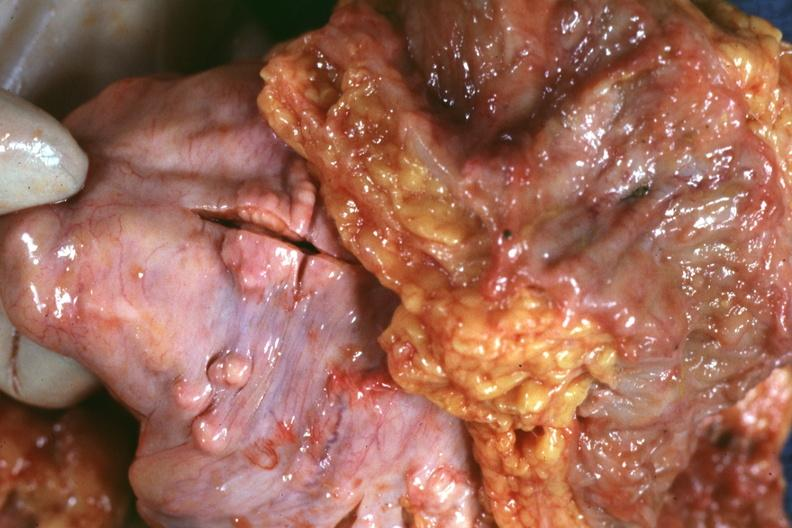s metastatic carcinoma prostate present?
Answer the question using a single word or phrase. Yes 